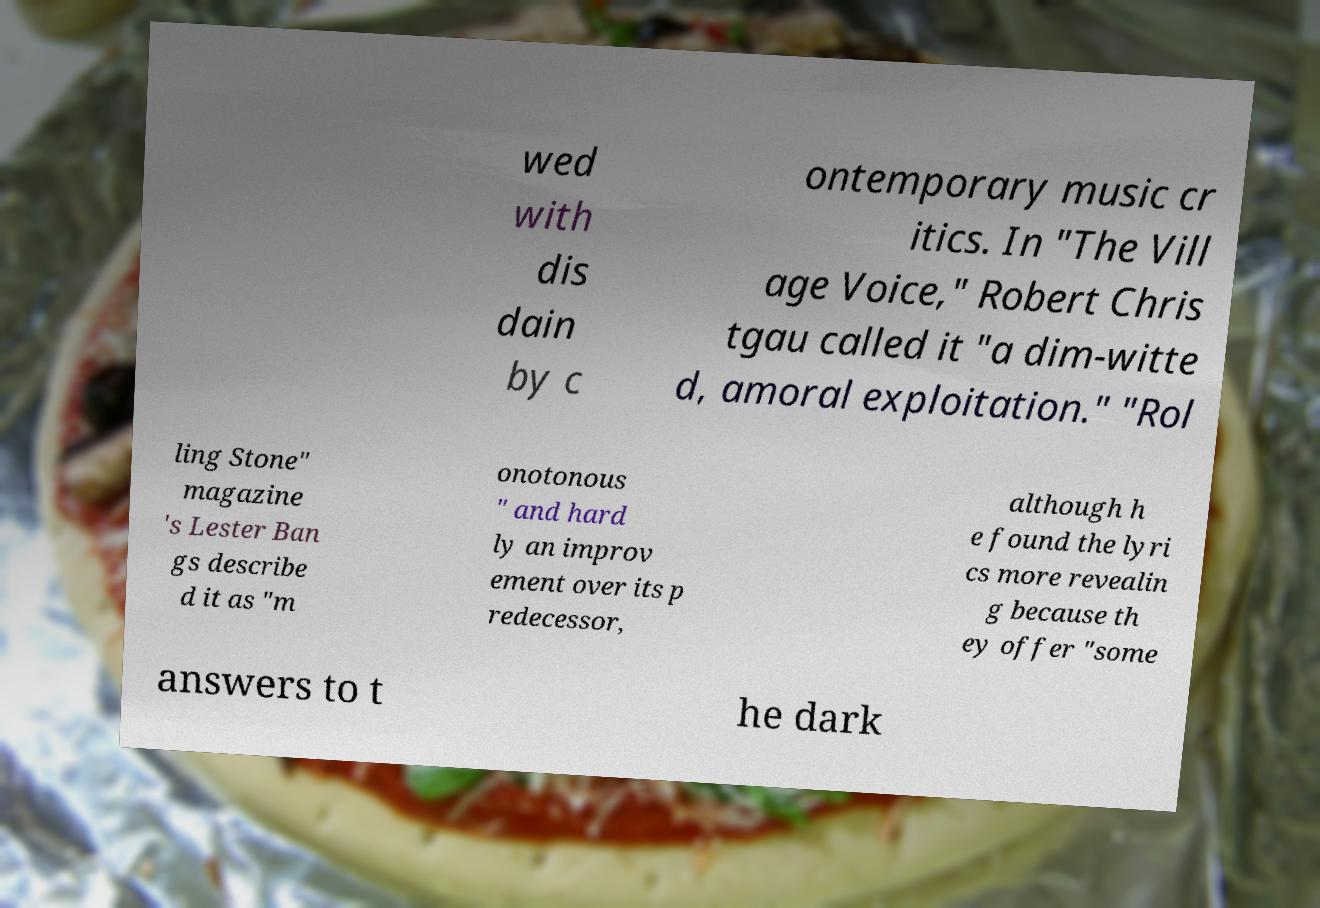There's text embedded in this image that I need extracted. Can you transcribe it verbatim? wed with dis dain by c ontemporary music cr itics. In "The Vill age Voice," Robert Chris tgau called it "a dim-witte d, amoral exploitation." "Rol ling Stone" magazine 's Lester Ban gs describe d it as "m onotonous " and hard ly an improv ement over its p redecessor, although h e found the lyri cs more revealin g because th ey offer "some answers to t he dark 